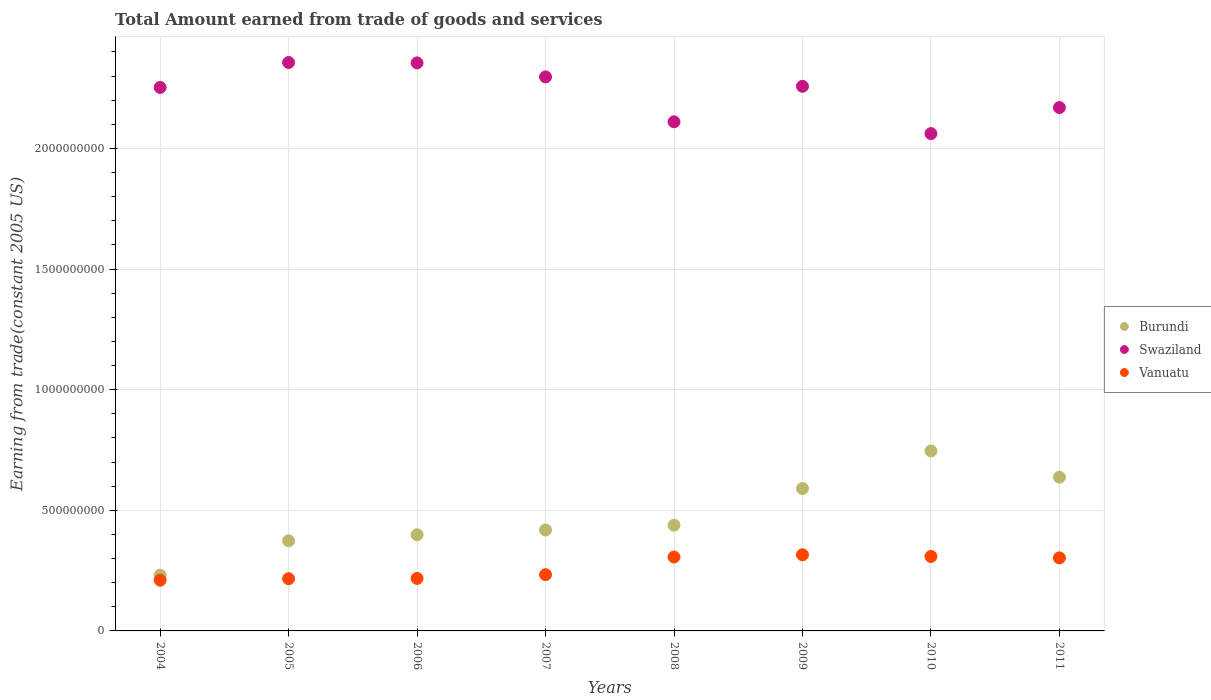How many different coloured dotlines are there?
Provide a short and direct response. 3. Is the number of dotlines equal to the number of legend labels?
Your answer should be compact. Yes. What is the total amount earned by trading goods and services in Burundi in 2004?
Your answer should be compact. 2.31e+08. Across all years, what is the maximum total amount earned by trading goods and services in Vanuatu?
Your answer should be very brief. 3.15e+08. Across all years, what is the minimum total amount earned by trading goods and services in Vanuatu?
Your answer should be compact. 2.10e+08. What is the total total amount earned by trading goods and services in Burundi in the graph?
Offer a terse response. 3.83e+09. What is the difference between the total amount earned by trading goods and services in Vanuatu in 2006 and that in 2007?
Offer a terse response. -1.54e+07. What is the difference between the total amount earned by trading goods and services in Swaziland in 2006 and the total amount earned by trading goods and services in Burundi in 2007?
Your response must be concise. 1.94e+09. What is the average total amount earned by trading goods and services in Burundi per year?
Make the answer very short. 4.79e+08. In the year 2007, what is the difference between the total amount earned by trading goods and services in Swaziland and total amount earned by trading goods and services in Burundi?
Give a very brief answer. 1.88e+09. In how many years, is the total amount earned by trading goods and services in Swaziland greater than 2300000000 US$?
Give a very brief answer. 2. What is the ratio of the total amount earned by trading goods and services in Vanuatu in 2004 to that in 2011?
Keep it short and to the point. 0.7. Is the total amount earned by trading goods and services in Swaziland in 2006 less than that in 2011?
Your answer should be very brief. No. Is the difference between the total amount earned by trading goods and services in Swaziland in 2006 and 2008 greater than the difference between the total amount earned by trading goods and services in Burundi in 2006 and 2008?
Make the answer very short. Yes. What is the difference between the highest and the second highest total amount earned by trading goods and services in Swaziland?
Give a very brief answer. 1.81e+06. What is the difference between the highest and the lowest total amount earned by trading goods and services in Vanuatu?
Offer a terse response. 1.05e+08. In how many years, is the total amount earned by trading goods and services in Swaziland greater than the average total amount earned by trading goods and services in Swaziland taken over all years?
Provide a succinct answer. 5. Is the total amount earned by trading goods and services in Vanuatu strictly greater than the total amount earned by trading goods and services in Swaziland over the years?
Your answer should be very brief. No. Is the total amount earned by trading goods and services in Burundi strictly less than the total amount earned by trading goods and services in Swaziland over the years?
Make the answer very short. Yes. How many dotlines are there?
Your response must be concise. 3. Where does the legend appear in the graph?
Ensure brevity in your answer.  Center right. How many legend labels are there?
Give a very brief answer. 3. How are the legend labels stacked?
Make the answer very short. Vertical. What is the title of the graph?
Provide a short and direct response. Total Amount earned from trade of goods and services. What is the label or title of the Y-axis?
Offer a terse response. Earning from trade(constant 2005 US). What is the Earning from trade(constant 2005 US) in Burundi in 2004?
Your response must be concise. 2.31e+08. What is the Earning from trade(constant 2005 US) in Swaziland in 2004?
Your answer should be compact. 2.25e+09. What is the Earning from trade(constant 2005 US) of Vanuatu in 2004?
Offer a terse response. 2.10e+08. What is the Earning from trade(constant 2005 US) of Burundi in 2005?
Your response must be concise. 3.74e+08. What is the Earning from trade(constant 2005 US) in Swaziland in 2005?
Your response must be concise. 2.36e+09. What is the Earning from trade(constant 2005 US) in Vanuatu in 2005?
Ensure brevity in your answer.  2.16e+08. What is the Earning from trade(constant 2005 US) of Burundi in 2006?
Keep it short and to the point. 3.99e+08. What is the Earning from trade(constant 2005 US) in Swaziland in 2006?
Your answer should be very brief. 2.35e+09. What is the Earning from trade(constant 2005 US) of Vanuatu in 2006?
Give a very brief answer. 2.18e+08. What is the Earning from trade(constant 2005 US) in Burundi in 2007?
Keep it short and to the point. 4.18e+08. What is the Earning from trade(constant 2005 US) in Swaziland in 2007?
Ensure brevity in your answer.  2.30e+09. What is the Earning from trade(constant 2005 US) of Vanuatu in 2007?
Ensure brevity in your answer.  2.33e+08. What is the Earning from trade(constant 2005 US) in Burundi in 2008?
Keep it short and to the point. 4.38e+08. What is the Earning from trade(constant 2005 US) of Swaziland in 2008?
Your response must be concise. 2.11e+09. What is the Earning from trade(constant 2005 US) of Vanuatu in 2008?
Offer a terse response. 3.06e+08. What is the Earning from trade(constant 2005 US) in Burundi in 2009?
Your answer should be very brief. 5.90e+08. What is the Earning from trade(constant 2005 US) in Swaziland in 2009?
Make the answer very short. 2.26e+09. What is the Earning from trade(constant 2005 US) in Vanuatu in 2009?
Provide a succinct answer. 3.15e+08. What is the Earning from trade(constant 2005 US) of Burundi in 2010?
Your response must be concise. 7.46e+08. What is the Earning from trade(constant 2005 US) of Swaziland in 2010?
Your answer should be very brief. 2.06e+09. What is the Earning from trade(constant 2005 US) of Vanuatu in 2010?
Offer a terse response. 3.09e+08. What is the Earning from trade(constant 2005 US) in Burundi in 2011?
Offer a terse response. 6.37e+08. What is the Earning from trade(constant 2005 US) in Swaziland in 2011?
Offer a very short reply. 2.17e+09. What is the Earning from trade(constant 2005 US) in Vanuatu in 2011?
Offer a very short reply. 3.03e+08. Across all years, what is the maximum Earning from trade(constant 2005 US) of Burundi?
Make the answer very short. 7.46e+08. Across all years, what is the maximum Earning from trade(constant 2005 US) in Swaziland?
Your response must be concise. 2.36e+09. Across all years, what is the maximum Earning from trade(constant 2005 US) of Vanuatu?
Provide a succinct answer. 3.15e+08. Across all years, what is the minimum Earning from trade(constant 2005 US) of Burundi?
Provide a succinct answer. 2.31e+08. Across all years, what is the minimum Earning from trade(constant 2005 US) of Swaziland?
Keep it short and to the point. 2.06e+09. Across all years, what is the minimum Earning from trade(constant 2005 US) in Vanuatu?
Provide a short and direct response. 2.10e+08. What is the total Earning from trade(constant 2005 US) of Burundi in the graph?
Make the answer very short. 3.83e+09. What is the total Earning from trade(constant 2005 US) of Swaziland in the graph?
Keep it short and to the point. 1.79e+1. What is the total Earning from trade(constant 2005 US) of Vanuatu in the graph?
Offer a very short reply. 2.11e+09. What is the difference between the Earning from trade(constant 2005 US) of Burundi in 2004 and that in 2005?
Provide a succinct answer. -1.43e+08. What is the difference between the Earning from trade(constant 2005 US) in Swaziland in 2004 and that in 2005?
Ensure brevity in your answer.  -1.04e+08. What is the difference between the Earning from trade(constant 2005 US) in Vanuatu in 2004 and that in 2005?
Ensure brevity in your answer.  -6.03e+06. What is the difference between the Earning from trade(constant 2005 US) of Burundi in 2004 and that in 2006?
Give a very brief answer. -1.67e+08. What is the difference between the Earning from trade(constant 2005 US) of Swaziland in 2004 and that in 2006?
Ensure brevity in your answer.  -1.02e+08. What is the difference between the Earning from trade(constant 2005 US) of Vanuatu in 2004 and that in 2006?
Give a very brief answer. -7.32e+06. What is the difference between the Earning from trade(constant 2005 US) in Burundi in 2004 and that in 2007?
Make the answer very short. -1.87e+08. What is the difference between the Earning from trade(constant 2005 US) in Swaziland in 2004 and that in 2007?
Ensure brevity in your answer.  -4.36e+07. What is the difference between the Earning from trade(constant 2005 US) in Vanuatu in 2004 and that in 2007?
Give a very brief answer. -2.28e+07. What is the difference between the Earning from trade(constant 2005 US) in Burundi in 2004 and that in 2008?
Give a very brief answer. -2.07e+08. What is the difference between the Earning from trade(constant 2005 US) in Swaziland in 2004 and that in 2008?
Provide a short and direct response. 1.42e+08. What is the difference between the Earning from trade(constant 2005 US) in Vanuatu in 2004 and that in 2008?
Your answer should be very brief. -9.61e+07. What is the difference between the Earning from trade(constant 2005 US) in Burundi in 2004 and that in 2009?
Provide a succinct answer. -3.59e+08. What is the difference between the Earning from trade(constant 2005 US) in Swaziland in 2004 and that in 2009?
Ensure brevity in your answer.  -4.71e+06. What is the difference between the Earning from trade(constant 2005 US) in Vanuatu in 2004 and that in 2009?
Offer a terse response. -1.05e+08. What is the difference between the Earning from trade(constant 2005 US) of Burundi in 2004 and that in 2010?
Offer a very short reply. -5.15e+08. What is the difference between the Earning from trade(constant 2005 US) of Swaziland in 2004 and that in 2010?
Give a very brief answer. 1.91e+08. What is the difference between the Earning from trade(constant 2005 US) in Vanuatu in 2004 and that in 2010?
Provide a succinct answer. -9.83e+07. What is the difference between the Earning from trade(constant 2005 US) in Burundi in 2004 and that in 2011?
Ensure brevity in your answer.  -4.06e+08. What is the difference between the Earning from trade(constant 2005 US) in Swaziland in 2004 and that in 2011?
Offer a terse response. 8.34e+07. What is the difference between the Earning from trade(constant 2005 US) of Vanuatu in 2004 and that in 2011?
Your response must be concise. -9.23e+07. What is the difference between the Earning from trade(constant 2005 US) in Burundi in 2005 and that in 2006?
Your answer should be compact. -2.49e+07. What is the difference between the Earning from trade(constant 2005 US) of Swaziland in 2005 and that in 2006?
Provide a short and direct response. 1.81e+06. What is the difference between the Earning from trade(constant 2005 US) of Vanuatu in 2005 and that in 2006?
Provide a short and direct response. -1.29e+06. What is the difference between the Earning from trade(constant 2005 US) in Burundi in 2005 and that in 2007?
Your answer should be very brief. -4.48e+07. What is the difference between the Earning from trade(constant 2005 US) in Swaziland in 2005 and that in 2007?
Offer a terse response. 5.99e+07. What is the difference between the Earning from trade(constant 2005 US) of Vanuatu in 2005 and that in 2007?
Your response must be concise. -1.67e+07. What is the difference between the Earning from trade(constant 2005 US) in Burundi in 2005 and that in 2008?
Provide a short and direct response. -6.44e+07. What is the difference between the Earning from trade(constant 2005 US) of Swaziland in 2005 and that in 2008?
Give a very brief answer. 2.46e+08. What is the difference between the Earning from trade(constant 2005 US) in Vanuatu in 2005 and that in 2008?
Offer a very short reply. -9.00e+07. What is the difference between the Earning from trade(constant 2005 US) of Burundi in 2005 and that in 2009?
Provide a short and direct response. -2.17e+08. What is the difference between the Earning from trade(constant 2005 US) of Swaziland in 2005 and that in 2009?
Your response must be concise. 9.89e+07. What is the difference between the Earning from trade(constant 2005 US) in Vanuatu in 2005 and that in 2009?
Provide a short and direct response. -9.91e+07. What is the difference between the Earning from trade(constant 2005 US) of Burundi in 2005 and that in 2010?
Provide a succinct answer. -3.72e+08. What is the difference between the Earning from trade(constant 2005 US) in Swaziland in 2005 and that in 2010?
Offer a terse response. 2.95e+08. What is the difference between the Earning from trade(constant 2005 US) of Vanuatu in 2005 and that in 2010?
Your answer should be very brief. -9.22e+07. What is the difference between the Earning from trade(constant 2005 US) in Burundi in 2005 and that in 2011?
Give a very brief answer. -2.64e+08. What is the difference between the Earning from trade(constant 2005 US) of Swaziland in 2005 and that in 2011?
Your response must be concise. 1.87e+08. What is the difference between the Earning from trade(constant 2005 US) in Vanuatu in 2005 and that in 2011?
Offer a very short reply. -8.63e+07. What is the difference between the Earning from trade(constant 2005 US) in Burundi in 2006 and that in 2007?
Make the answer very short. -1.99e+07. What is the difference between the Earning from trade(constant 2005 US) of Swaziland in 2006 and that in 2007?
Ensure brevity in your answer.  5.81e+07. What is the difference between the Earning from trade(constant 2005 US) of Vanuatu in 2006 and that in 2007?
Offer a terse response. -1.54e+07. What is the difference between the Earning from trade(constant 2005 US) of Burundi in 2006 and that in 2008?
Offer a very short reply. -3.96e+07. What is the difference between the Earning from trade(constant 2005 US) of Swaziland in 2006 and that in 2008?
Keep it short and to the point. 2.44e+08. What is the difference between the Earning from trade(constant 2005 US) in Vanuatu in 2006 and that in 2008?
Offer a very short reply. -8.87e+07. What is the difference between the Earning from trade(constant 2005 US) of Burundi in 2006 and that in 2009?
Your answer should be very brief. -1.92e+08. What is the difference between the Earning from trade(constant 2005 US) of Swaziland in 2006 and that in 2009?
Your answer should be compact. 9.70e+07. What is the difference between the Earning from trade(constant 2005 US) in Vanuatu in 2006 and that in 2009?
Offer a very short reply. -9.78e+07. What is the difference between the Earning from trade(constant 2005 US) in Burundi in 2006 and that in 2010?
Provide a succinct answer. -3.47e+08. What is the difference between the Earning from trade(constant 2005 US) in Swaziland in 2006 and that in 2010?
Make the answer very short. 2.93e+08. What is the difference between the Earning from trade(constant 2005 US) of Vanuatu in 2006 and that in 2010?
Provide a short and direct response. -9.09e+07. What is the difference between the Earning from trade(constant 2005 US) in Burundi in 2006 and that in 2011?
Provide a short and direct response. -2.39e+08. What is the difference between the Earning from trade(constant 2005 US) in Swaziland in 2006 and that in 2011?
Keep it short and to the point. 1.85e+08. What is the difference between the Earning from trade(constant 2005 US) of Vanuatu in 2006 and that in 2011?
Provide a short and direct response. -8.50e+07. What is the difference between the Earning from trade(constant 2005 US) of Burundi in 2007 and that in 2008?
Give a very brief answer. -1.96e+07. What is the difference between the Earning from trade(constant 2005 US) in Swaziland in 2007 and that in 2008?
Offer a terse response. 1.86e+08. What is the difference between the Earning from trade(constant 2005 US) in Vanuatu in 2007 and that in 2008?
Make the answer very short. -7.33e+07. What is the difference between the Earning from trade(constant 2005 US) in Burundi in 2007 and that in 2009?
Ensure brevity in your answer.  -1.72e+08. What is the difference between the Earning from trade(constant 2005 US) in Swaziland in 2007 and that in 2009?
Keep it short and to the point. 3.89e+07. What is the difference between the Earning from trade(constant 2005 US) of Vanuatu in 2007 and that in 2009?
Your answer should be compact. -8.23e+07. What is the difference between the Earning from trade(constant 2005 US) in Burundi in 2007 and that in 2010?
Your response must be concise. -3.27e+08. What is the difference between the Earning from trade(constant 2005 US) in Swaziland in 2007 and that in 2010?
Keep it short and to the point. 2.35e+08. What is the difference between the Earning from trade(constant 2005 US) of Vanuatu in 2007 and that in 2010?
Your answer should be very brief. -7.55e+07. What is the difference between the Earning from trade(constant 2005 US) of Burundi in 2007 and that in 2011?
Your response must be concise. -2.19e+08. What is the difference between the Earning from trade(constant 2005 US) in Swaziland in 2007 and that in 2011?
Ensure brevity in your answer.  1.27e+08. What is the difference between the Earning from trade(constant 2005 US) in Vanuatu in 2007 and that in 2011?
Ensure brevity in your answer.  -6.95e+07. What is the difference between the Earning from trade(constant 2005 US) in Burundi in 2008 and that in 2009?
Your answer should be very brief. -1.52e+08. What is the difference between the Earning from trade(constant 2005 US) in Swaziland in 2008 and that in 2009?
Provide a succinct answer. -1.47e+08. What is the difference between the Earning from trade(constant 2005 US) of Vanuatu in 2008 and that in 2009?
Make the answer very short. -9.04e+06. What is the difference between the Earning from trade(constant 2005 US) in Burundi in 2008 and that in 2010?
Offer a terse response. -3.08e+08. What is the difference between the Earning from trade(constant 2005 US) in Swaziland in 2008 and that in 2010?
Make the answer very short. 4.89e+07. What is the difference between the Earning from trade(constant 2005 US) in Vanuatu in 2008 and that in 2010?
Your response must be concise. -2.21e+06. What is the difference between the Earning from trade(constant 2005 US) of Burundi in 2008 and that in 2011?
Your answer should be compact. -1.99e+08. What is the difference between the Earning from trade(constant 2005 US) in Swaziland in 2008 and that in 2011?
Your answer should be very brief. -5.91e+07. What is the difference between the Earning from trade(constant 2005 US) in Vanuatu in 2008 and that in 2011?
Your answer should be very brief. 3.74e+06. What is the difference between the Earning from trade(constant 2005 US) in Burundi in 2009 and that in 2010?
Provide a short and direct response. -1.56e+08. What is the difference between the Earning from trade(constant 2005 US) of Swaziland in 2009 and that in 2010?
Ensure brevity in your answer.  1.96e+08. What is the difference between the Earning from trade(constant 2005 US) of Vanuatu in 2009 and that in 2010?
Offer a very short reply. 6.83e+06. What is the difference between the Earning from trade(constant 2005 US) in Burundi in 2009 and that in 2011?
Make the answer very short. -4.70e+07. What is the difference between the Earning from trade(constant 2005 US) of Swaziland in 2009 and that in 2011?
Keep it short and to the point. 8.81e+07. What is the difference between the Earning from trade(constant 2005 US) of Vanuatu in 2009 and that in 2011?
Provide a succinct answer. 1.28e+07. What is the difference between the Earning from trade(constant 2005 US) of Burundi in 2010 and that in 2011?
Give a very brief answer. 1.09e+08. What is the difference between the Earning from trade(constant 2005 US) in Swaziland in 2010 and that in 2011?
Offer a very short reply. -1.08e+08. What is the difference between the Earning from trade(constant 2005 US) in Vanuatu in 2010 and that in 2011?
Your response must be concise. 5.95e+06. What is the difference between the Earning from trade(constant 2005 US) of Burundi in 2004 and the Earning from trade(constant 2005 US) of Swaziland in 2005?
Provide a short and direct response. -2.13e+09. What is the difference between the Earning from trade(constant 2005 US) in Burundi in 2004 and the Earning from trade(constant 2005 US) in Vanuatu in 2005?
Ensure brevity in your answer.  1.47e+07. What is the difference between the Earning from trade(constant 2005 US) in Swaziland in 2004 and the Earning from trade(constant 2005 US) in Vanuatu in 2005?
Provide a succinct answer. 2.04e+09. What is the difference between the Earning from trade(constant 2005 US) in Burundi in 2004 and the Earning from trade(constant 2005 US) in Swaziland in 2006?
Offer a terse response. -2.12e+09. What is the difference between the Earning from trade(constant 2005 US) in Burundi in 2004 and the Earning from trade(constant 2005 US) in Vanuatu in 2006?
Your answer should be very brief. 1.34e+07. What is the difference between the Earning from trade(constant 2005 US) of Swaziland in 2004 and the Earning from trade(constant 2005 US) of Vanuatu in 2006?
Keep it short and to the point. 2.04e+09. What is the difference between the Earning from trade(constant 2005 US) in Burundi in 2004 and the Earning from trade(constant 2005 US) in Swaziland in 2007?
Give a very brief answer. -2.07e+09. What is the difference between the Earning from trade(constant 2005 US) of Burundi in 2004 and the Earning from trade(constant 2005 US) of Vanuatu in 2007?
Provide a short and direct response. -2.07e+06. What is the difference between the Earning from trade(constant 2005 US) in Swaziland in 2004 and the Earning from trade(constant 2005 US) in Vanuatu in 2007?
Provide a short and direct response. 2.02e+09. What is the difference between the Earning from trade(constant 2005 US) in Burundi in 2004 and the Earning from trade(constant 2005 US) in Swaziland in 2008?
Give a very brief answer. -1.88e+09. What is the difference between the Earning from trade(constant 2005 US) of Burundi in 2004 and the Earning from trade(constant 2005 US) of Vanuatu in 2008?
Give a very brief answer. -7.54e+07. What is the difference between the Earning from trade(constant 2005 US) in Swaziland in 2004 and the Earning from trade(constant 2005 US) in Vanuatu in 2008?
Offer a very short reply. 1.95e+09. What is the difference between the Earning from trade(constant 2005 US) in Burundi in 2004 and the Earning from trade(constant 2005 US) in Swaziland in 2009?
Keep it short and to the point. -2.03e+09. What is the difference between the Earning from trade(constant 2005 US) of Burundi in 2004 and the Earning from trade(constant 2005 US) of Vanuatu in 2009?
Your answer should be very brief. -8.44e+07. What is the difference between the Earning from trade(constant 2005 US) of Swaziland in 2004 and the Earning from trade(constant 2005 US) of Vanuatu in 2009?
Offer a terse response. 1.94e+09. What is the difference between the Earning from trade(constant 2005 US) in Burundi in 2004 and the Earning from trade(constant 2005 US) in Swaziland in 2010?
Provide a short and direct response. -1.83e+09. What is the difference between the Earning from trade(constant 2005 US) of Burundi in 2004 and the Earning from trade(constant 2005 US) of Vanuatu in 2010?
Offer a very short reply. -7.76e+07. What is the difference between the Earning from trade(constant 2005 US) of Swaziland in 2004 and the Earning from trade(constant 2005 US) of Vanuatu in 2010?
Make the answer very short. 1.94e+09. What is the difference between the Earning from trade(constant 2005 US) of Burundi in 2004 and the Earning from trade(constant 2005 US) of Swaziland in 2011?
Offer a terse response. -1.94e+09. What is the difference between the Earning from trade(constant 2005 US) in Burundi in 2004 and the Earning from trade(constant 2005 US) in Vanuatu in 2011?
Your answer should be compact. -7.16e+07. What is the difference between the Earning from trade(constant 2005 US) of Swaziland in 2004 and the Earning from trade(constant 2005 US) of Vanuatu in 2011?
Ensure brevity in your answer.  1.95e+09. What is the difference between the Earning from trade(constant 2005 US) in Burundi in 2005 and the Earning from trade(constant 2005 US) in Swaziland in 2006?
Make the answer very short. -1.98e+09. What is the difference between the Earning from trade(constant 2005 US) in Burundi in 2005 and the Earning from trade(constant 2005 US) in Vanuatu in 2006?
Your response must be concise. 1.56e+08. What is the difference between the Earning from trade(constant 2005 US) in Swaziland in 2005 and the Earning from trade(constant 2005 US) in Vanuatu in 2006?
Offer a terse response. 2.14e+09. What is the difference between the Earning from trade(constant 2005 US) of Burundi in 2005 and the Earning from trade(constant 2005 US) of Swaziland in 2007?
Offer a very short reply. -1.92e+09. What is the difference between the Earning from trade(constant 2005 US) of Burundi in 2005 and the Earning from trade(constant 2005 US) of Vanuatu in 2007?
Provide a succinct answer. 1.41e+08. What is the difference between the Earning from trade(constant 2005 US) of Swaziland in 2005 and the Earning from trade(constant 2005 US) of Vanuatu in 2007?
Give a very brief answer. 2.12e+09. What is the difference between the Earning from trade(constant 2005 US) in Burundi in 2005 and the Earning from trade(constant 2005 US) in Swaziland in 2008?
Your response must be concise. -1.74e+09. What is the difference between the Earning from trade(constant 2005 US) of Burundi in 2005 and the Earning from trade(constant 2005 US) of Vanuatu in 2008?
Provide a short and direct response. 6.72e+07. What is the difference between the Earning from trade(constant 2005 US) in Swaziland in 2005 and the Earning from trade(constant 2005 US) in Vanuatu in 2008?
Provide a short and direct response. 2.05e+09. What is the difference between the Earning from trade(constant 2005 US) of Burundi in 2005 and the Earning from trade(constant 2005 US) of Swaziland in 2009?
Offer a terse response. -1.88e+09. What is the difference between the Earning from trade(constant 2005 US) of Burundi in 2005 and the Earning from trade(constant 2005 US) of Vanuatu in 2009?
Keep it short and to the point. 5.82e+07. What is the difference between the Earning from trade(constant 2005 US) of Swaziland in 2005 and the Earning from trade(constant 2005 US) of Vanuatu in 2009?
Keep it short and to the point. 2.04e+09. What is the difference between the Earning from trade(constant 2005 US) of Burundi in 2005 and the Earning from trade(constant 2005 US) of Swaziland in 2010?
Offer a terse response. -1.69e+09. What is the difference between the Earning from trade(constant 2005 US) in Burundi in 2005 and the Earning from trade(constant 2005 US) in Vanuatu in 2010?
Make the answer very short. 6.50e+07. What is the difference between the Earning from trade(constant 2005 US) in Swaziland in 2005 and the Earning from trade(constant 2005 US) in Vanuatu in 2010?
Make the answer very short. 2.05e+09. What is the difference between the Earning from trade(constant 2005 US) in Burundi in 2005 and the Earning from trade(constant 2005 US) in Swaziland in 2011?
Offer a terse response. -1.80e+09. What is the difference between the Earning from trade(constant 2005 US) in Burundi in 2005 and the Earning from trade(constant 2005 US) in Vanuatu in 2011?
Make the answer very short. 7.10e+07. What is the difference between the Earning from trade(constant 2005 US) in Swaziland in 2005 and the Earning from trade(constant 2005 US) in Vanuatu in 2011?
Provide a succinct answer. 2.05e+09. What is the difference between the Earning from trade(constant 2005 US) in Burundi in 2006 and the Earning from trade(constant 2005 US) in Swaziland in 2007?
Provide a succinct answer. -1.90e+09. What is the difference between the Earning from trade(constant 2005 US) in Burundi in 2006 and the Earning from trade(constant 2005 US) in Vanuatu in 2007?
Your answer should be compact. 1.65e+08. What is the difference between the Earning from trade(constant 2005 US) in Swaziland in 2006 and the Earning from trade(constant 2005 US) in Vanuatu in 2007?
Ensure brevity in your answer.  2.12e+09. What is the difference between the Earning from trade(constant 2005 US) in Burundi in 2006 and the Earning from trade(constant 2005 US) in Swaziland in 2008?
Ensure brevity in your answer.  -1.71e+09. What is the difference between the Earning from trade(constant 2005 US) in Burundi in 2006 and the Earning from trade(constant 2005 US) in Vanuatu in 2008?
Offer a very short reply. 9.21e+07. What is the difference between the Earning from trade(constant 2005 US) in Swaziland in 2006 and the Earning from trade(constant 2005 US) in Vanuatu in 2008?
Make the answer very short. 2.05e+09. What is the difference between the Earning from trade(constant 2005 US) of Burundi in 2006 and the Earning from trade(constant 2005 US) of Swaziland in 2009?
Your answer should be very brief. -1.86e+09. What is the difference between the Earning from trade(constant 2005 US) in Burundi in 2006 and the Earning from trade(constant 2005 US) in Vanuatu in 2009?
Provide a short and direct response. 8.31e+07. What is the difference between the Earning from trade(constant 2005 US) in Swaziland in 2006 and the Earning from trade(constant 2005 US) in Vanuatu in 2009?
Your response must be concise. 2.04e+09. What is the difference between the Earning from trade(constant 2005 US) of Burundi in 2006 and the Earning from trade(constant 2005 US) of Swaziland in 2010?
Your answer should be compact. -1.66e+09. What is the difference between the Earning from trade(constant 2005 US) of Burundi in 2006 and the Earning from trade(constant 2005 US) of Vanuatu in 2010?
Offer a very short reply. 8.99e+07. What is the difference between the Earning from trade(constant 2005 US) of Swaziland in 2006 and the Earning from trade(constant 2005 US) of Vanuatu in 2010?
Offer a terse response. 2.05e+09. What is the difference between the Earning from trade(constant 2005 US) of Burundi in 2006 and the Earning from trade(constant 2005 US) of Swaziland in 2011?
Make the answer very short. -1.77e+09. What is the difference between the Earning from trade(constant 2005 US) in Burundi in 2006 and the Earning from trade(constant 2005 US) in Vanuatu in 2011?
Offer a terse response. 9.58e+07. What is the difference between the Earning from trade(constant 2005 US) of Swaziland in 2006 and the Earning from trade(constant 2005 US) of Vanuatu in 2011?
Give a very brief answer. 2.05e+09. What is the difference between the Earning from trade(constant 2005 US) of Burundi in 2007 and the Earning from trade(constant 2005 US) of Swaziland in 2008?
Your answer should be very brief. -1.69e+09. What is the difference between the Earning from trade(constant 2005 US) in Burundi in 2007 and the Earning from trade(constant 2005 US) in Vanuatu in 2008?
Make the answer very short. 1.12e+08. What is the difference between the Earning from trade(constant 2005 US) of Swaziland in 2007 and the Earning from trade(constant 2005 US) of Vanuatu in 2008?
Give a very brief answer. 1.99e+09. What is the difference between the Earning from trade(constant 2005 US) in Burundi in 2007 and the Earning from trade(constant 2005 US) in Swaziland in 2009?
Your answer should be compact. -1.84e+09. What is the difference between the Earning from trade(constant 2005 US) of Burundi in 2007 and the Earning from trade(constant 2005 US) of Vanuatu in 2009?
Your answer should be very brief. 1.03e+08. What is the difference between the Earning from trade(constant 2005 US) of Swaziland in 2007 and the Earning from trade(constant 2005 US) of Vanuatu in 2009?
Your answer should be very brief. 1.98e+09. What is the difference between the Earning from trade(constant 2005 US) in Burundi in 2007 and the Earning from trade(constant 2005 US) in Swaziland in 2010?
Your answer should be compact. -1.64e+09. What is the difference between the Earning from trade(constant 2005 US) of Burundi in 2007 and the Earning from trade(constant 2005 US) of Vanuatu in 2010?
Offer a very short reply. 1.10e+08. What is the difference between the Earning from trade(constant 2005 US) in Swaziland in 2007 and the Earning from trade(constant 2005 US) in Vanuatu in 2010?
Offer a terse response. 1.99e+09. What is the difference between the Earning from trade(constant 2005 US) of Burundi in 2007 and the Earning from trade(constant 2005 US) of Swaziland in 2011?
Offer a very short reply. -1.75e+09. What is the difference between the Earning from trade(constant 2005 US) of Burundi in 2007 and the Earning from trade(constant 2005 US) of Vanuatu in 2011?
Provide a short and direct response. 1.16e+08. What is the difference between the Earning from trade(constant 2005 US) in Swaziland in 2007 and the Earning from trade(constant 2005 US) in Vanuatu in 2011?
Your answer should be compact. 1.99e+09. What is the difference between the Earning from trade(constant 2005 US) of Burundi in 2008 and the Earning from trade(constant 2005 US) of Swaziland in 2009?
Your answer should be very brief. -1.82e+09. What is the difference between the Earning from trade(constant 2005 US) in Burundi in 2008 and the Earning from trade(constant 2005 US) in Vanuatu in 2009?
Your answer should be compact. 1.23e+08. What is the difference between the Earning from trade(constant 2005 US) of Swaziland in 2008 and the Earning from trade(constant 2005 US) of Vanuatu in 2009?
Offer a very short reply. 1.79e+09. What is the difference between the Earning from trade(constant 2005 US) of Burundi in 2008 and the Earning from trade(constant 2005 US) of Swaziland in 2010?
Your answer should be compact. -1.62e+09. What is the difference between the Earning from trade(constant 2005 US) in Burundi in 2008 and the Earning from trade(constant 2005 US) in Vanuatu in 2010?
Ensure brevity in your answer.  1.29e+08. What is the difference between the Earning from trade(constant 2005 US) in Swaziland in 2008 and the Earning from trade(constant 2005 US) in Vanuatu in 2010?
Provide a succinct answer. 1.80e+09. What is the difference between the Earning from trade(constant 2005 US) in Burundi in 2008 and the Earning from trade(constant 2005 US) in Swaziland in 2011?
Your answer should be compact. -1.73e+09. What is the difference between the Earning from trade(constant 2005 US) in Burundi in 2008 and the Earning from trade(constant 2005 US) in Vanuatu in 2011?
Give a very brief answer. 1.35e+08. What is the difference between the Earning from trade(constant 2005 US) in Swaziland in 2008 and the Earning from trade(constant 2005 US) in Vanuatu in 2011?
Give a very brief answer. 1.81e+09. What is the difference between the Earning from trade(constant 2005 US) of Burundi in 2009 and the Earning from trade(constant 2005 US) of Swaziland in 2010?
Provide a short and direct response. -1.47e+09. What is the difference between the Earning from trade(constant 2005 US) of Burundi in 2009 and the Earning from trade(constant 2005 US) of Vanuatu in 2010?
Give a very brief answer. 2.82e+08. What is the difference between the Earning from trade(constant 2005 US) of Swaziland in 2009 and the Earning from trade(constant 2005 US) of Vanuatu in 2010?
Offer a terse response. 1.95e+09. What is the difference between the Earning from trade(constant 2005 US) of Burundi in 2009 and the Earning from trade(constant 2005 US) of Swaziland in 2011?
Make the answer very short. -1.58e+09. What is the difference between the Earning from trade(constant 2005 US) in Burundi in 2009 and the Earning from trade(constant 2005 US) in Vanuatu in 2011?
Provide a short and direct response. 2.87e+08. What is the difference between the Earning from trade(constant 2005 US) of Swaziland in 2009 and the Earning from trade(constant 2005 US) of Vanuatu in 2011?
Ensure brevity in your answer.  1.95e+09. What is the difference between the Earning from trade(constant 2005 US) in Burundi in 2010 and the Earning from trade(constant 2005 US) in Swaziland in 2011?
Ensure brevity in your answer.  -1.42e+09. What is the difference between the Earning from trade(constant 2005 US) of Burundi in 2010 and the Earning from trade(constant 2005 US) of Vanuatu in 2011?
Provide a succinct answer. 4.43e+08. What is the difference between the Earning from trade(constant 2005 US) of Swaziland in 2010 and the Earning from trade(constant 2005 US) of Vanuatu in 2011?
Your answer should be very brief. 1.76e+09. What is the average Earning from trade(constant 2005 US) of Burundi per year?
Provide a succinct answer. 4.79e+08. What is the average Earning from trade(constant 2005 US) in Swaziland per year?
Keep it short and to the point. 2.23e+09. What is the average Earning from trade(constant 2005 US) in Vanuatu per year?
Provide a succinct answer. 2.64e+08. In the year 2004, what is the difference between the Earning from trade(constant 2005 US) of Burundi and Earning from trade(constant 2005 US) of Swaziland?
Give a very brief answer. -2.02e+09. In the year 2004, what is the difference between the Earning from trade(constant 2005 US) of Burundi and Earning from trade(constant 2005 US) of Vanuatu?
Provide a short and direct response. 2.07e+07. In the year 2004, what is the difference between the Earning from trade(constant 2005 US) of Swaziland and Earning from trade(constant 2005 US) of Vanuatu?
Make the answer very short. 2.04e+09. In the year 2005, what is the difference between the Earning from trade(constant 2005 US) of Burundi and Earning from trade(constant 2005 US) of Swaziland?
Offer a very short reply. -1.98e+09. In the year 2005, what is the difference between the Earning from trade(constant 2005 US) of Burundi and Earning from trade(constant 2005 US) of Vanuatu?
Your answer should be very brief. 1.57e+08. In the year 2005, what is the difference between the Earning from trade(constant 2005 US) in Swaziland and Earning from trade(constant 2005 US) in Vanuatu?
Offer a terse response. 2.14e+09. In the year 2006, what is the difference between the Earning from trade(constant 2005 US) of Burundi and Earning from trade(constant 2005 US) of Swaziland?
Your response must be concise. -1.96e+09. In the year 2006, what is the difference between the Earning from trade(constant 2005 US) of Burundi and Earning from trade(constant 2005 US) of Vanuatu?
Give a very brief answer. 1.81e+08. In the year 2006, what is the difference between the Earning from trade(constant 2005 US) in Swaziland and Earning from trade(constant 2005 US) in Vanuatu?
Keep it short and to the point. 2.14e+09. In the year 2007, what is the difference between the Earning from trade(constant 2005 US) in Burundi and Earning from trade(constant 2005 US) in Swaziland?
Your answer should be compact. -1.88e+09. In the year 2007, what is the difference between the Earning from trade(constant 2005 US) in Burundi and Earning from trade(constant 2005 US) in Vanuatu?
Provide a short and direct response. 1.85e+08. In the year 2007, what is the difference between the Earning from trade(constant 2005 US) in Swaziland and Earning from trade(constant 2005 US) in Vanuatu?
Make the answer very short. 2.06e+09. In the year 2008, what is the difference between the Earning from trade(constant 2005 US) in Burundi and Earning from trade(constant 2005 US) in Swaziland?
Your answer should be very brief. -1.67e+09. In the year 2008, what is the difference between the Earning from trade(constant 2005 US) in Burundi and Earning from trade(constant 2005 US) in Vanuatu?
Make the answer very short. 1.32e+08. In the year 2008, what is the difference between the Earning from trade(constant 2005 US) of Swaziland and Earning from trade(constant 2005 US) of Vanuatu?
Keep it short and to the point. 1.80e+09. In the year 2009, what is the difference between the Earning from trade(constant 2005 US) of Burundi and Earning from trade(constant 2005 US) of Swaziland?
Make the answer very short. -1.67e+09. In the year 2009, what is the difference between the Earning from trade(constant 2005 US) of Burundi and Earning from trade(constant 2005 US) of Vanuatu?
Offer a very short reply. 2.75e+08. In the year 2009, what is the difference between the Earning from trade(constant 2005 US) of Swaziland and Earning from trade(constant 2005 US) of Vanuatu?
Ensure brevity in your answer.  1.94e+09. In the year 2010, what is the difference between the Earning from trade(constant 2005 US) in Burundi and Earning from trade(constant 2005 US) in Swaziland?
Your answer should be compact. -1.32e+09. In the year 2010, what is the difference between the Earning from trade(constant 2005 US) of Burundi and Earning from trade(constant 2005 US) of Vanuatu?
Your answer should be compact. 4.37e+08. In the year 2010, what is the difference between the Earning from trade(constant 2005 US) in Swaziland and Earning from trade(constant 2005 US) in Vanuatu?
Offer a very short reply. 1.75e+09. In the year 2011, what is the difference between the Earning from trade(constant 2005 US) of Burundi and Earning from trade(constant 2005 US) of Swaziland?
Your answer should be compact. -1.53e+09. In the year 2011, what is the difference between the Earning from trade(constant 2005 US) of Burundi and Earning from trade(constant 2005 US) of Vanuatu?
Offer a very short reply. 3.34e+08. In the year 2011, what is the difference between the Earning from trade(constant 2005 US) of Swaziland and Earning from trade(constant 2005 US) of Vanuatu?
Provide a succinct answer. 1.87e+09. What is the ratio of the Earning from trade(constant 2005 US) in Burundi in 2004 to that in 2005?
Offer a very short reply. 0.62. What is the ratio of the Earning from trade(constant 2005 US) in Swaziland in 2004 to that in 2005?
Provide a succinct answer. 0.96. What is the ratio of the Earning from trade(constant 2005 US) of Vanuatu in 2004 to that in 2005?
Make the answer very short. 0.97. What is the ratio of the Earning from trade(constant 2005 US) of Burundi in 2004 to that in 2006?
Give a very brief answer. 0.58. What is the ratio of the Earning from trade(constant 2005 US) in Swaziland in 2004 to that in 2006?
Offer a terse response. 0.96. What is the ratio of the Earning from trade(constant 2005 US) in Vanuatu in 2004 to that in 2006?
Offer a terse response. 0.97. What is the ratio of the Earning from trade(constant 2005 US) of Burundi in 2004 to that in 2007?
Provide a short and direct response. 0.55. What is the ratio of the Earning from trade(constant 2005 US) in Vanuatu in 2004 to that in 2007?
Keep it short and to the point. 0.9. What is the ratio of the Earning from trade(constant 2005 US) in Burundi in 2004 to that in 2008?
Your answer should be compact. 0.53. What is the ratio of the Earning from trade(constant 2005 US) of Swaziland in 2004 to that in 2008?
Give a very brief answer. 1.07. What is the ratio of the Earning from trade(constant 2005 US) of Vanuatu in 2004 to that in 2008?
Keep it short and to the point. 0.69. What is the ratio of the Earning from trade(constant 2005 US) of Burundi in 2004 to that in 2009?
Make the answer very short. 0.39. What is the ratio of the Earning from trade(constant 2005 US) in Swaziland in 2004 to that in 2009?
Your answer should be very brief. 1. What is the ratio of the Earning from trade(constant 2005 US) of Vanuatu in 2004 to that in 2009?
Provide a short and direct response. 0.67. What is the ratio of the Earning from trade(constant 2005 US) of Burundi in 2004 to that in 2010?
Ensure brevity in your answer.  0.31. What is the ratio of the Earning from trade(constant 2005 US) in Swaziland in 2004 to that in 2010?
Your answer should be compact. 1.09. What is the ratio of the Earning from trade(constant 2005 US) in Vanuatu in 2004 to that in 2010?
Provide a succinct answer. 0.68. What is the ratio of the Earning from trade(constant 2005 US) in Burundi in 2004 to that in 2011?
Your answer should be compact. 0.36. What is the ratio of the Earning from trade(constant 2005 US) in Swaziland in 2004 to that in 2011?
Offer a very short reply. 1.04. What is the ratio of the Earning from trade(constant 2005 US) in Vanuatu in 2004 to that in 2011?
Your answer should be very brief. 0.69. What is the ratio of the Earning from trade(constant 2005 US) in Burundi in 2005 to that in 2006?
Your response must be concise. 0.94. What is the ratio of the Earning from trade(constant 2005 US) in Swaziland in 2005 to that in 2006?
Ensure brevity in your answer.  1. What is the ratio of the Earning from trade(constant 2005 US) in Vanuatu in 2005 to that in 2006?
Give a very brief answer. 0.99. What is the ratio of the Earning from trade(constant 2005 US) in Burundi in 2005 to that in 2007?
Provide a short and direct response. 0.89. What is the ratio of the Earning from trade(constant 2005 US) of Swaziland in 2005 to that in 2007?
Your answer should be very brief. 1.03. What is the ratio of the Earning from trade(constant 2005 US) in Vanuatu in 2005 to that in 2007?
Provide a short and direct response. 0.93. What is the ratio of the Earning from trade(constant 2005 US) of Burundi in 2005 to that in 2008?
Ensure brevity in your answer.  0.85. What is the ratio of the Earning from trade(constant 2005 US) in Swaziland in 2005 to that in 2008?
Your response must be concise. 1.12. What is the ratio of the Earning from trade(constant 2005 US) of Vanuatu in 2005 to that in 2008?
Provide a short and direct response. 0.71. What is the ratio of the Earning from trade(constant 2005 US) of Burundi in 2005 to that in 2009?
Provide a short and direct response. 0.63. What is the ratio of the Earning from trade(constant 2005 US) in Swaziland in 2005 to that in 2009?
Offer a terse response. 1.04. What is the ratio of the Earning from trade(constant 2005 US) of Vanuatu in 2005 to that in 2009?
Provide a short and direct response. 0.69. What is the ratio of the Earning from trade(constant 2005 US) in Burundi in 2005 to that in 2010?
Provide a short and direct response. 0.5. What is the ratio of the Earning from trade(constant 2005 US) in Swaziland in 2005 to that in 2010?
Provide a succinct answer. 1.14. What is the ratio of the Earning from trade(constant 2005 US) in Vanuatu in 2005 to that in 2010?
Your answer should be very brief. 0.7. What is the ratio of the Earning from trade(constant 2005 US) of Burundi in 2005 to that in 2011?
Ensure brevity in your answer.  0.59. What is the ratio of the Earning from trade(constant 2005 US) in Swaziland in 2005 to that in 2011?
Offer a terse response. 1.09. What is the ratio of the Earning from trade(constant 2005 US) of Vanuatu in 2005 to that in 2011?
Provide a short and direct response. 0.71. What is the ratio of the Earning from trade(constant 2005 US) of Burundi in 2006 to that in 2007?
Your answer should be very brief. 0.95. What is the ratio of the Earning from trade(constant 2005 US) in Swaziland in 2006 to that in 2007?
Make the answer very short. 1.03. What is the ratio of the Earning from trade(constant 2005 US) in Vanuatu in 2006 to that in 2007?
Your answer should be very brief. 0.93. What is the ratio of the Earning from trade(constant 2005 US) in Burundi in 2006 to that in 2008?
Give a very brief answer. 0.91. What is the ratio of the Earning from trade(constant 2005 US) of Swaziland in 2006 to that in 2008?
Your response must be concise. 1.12. What is the ratio of the Earning from trade(constant 2005 US) of Vanuatu in 2006 to that in 2008?
Make the answer very short. 0.71. What is the ratio of the Earning from trade(constant 2005 US) in Burundi in 2006 to that in 2009?
Provide a succinct answer. 0.68. What is the ratio of the Earning from trade(constant 2005 US) in Swaziland in 2006 to that in 2009?
Keep it short and to the point. 1.04. What is the ratio of the Earning from trade(constant 2005 US) of Vanuatu in 2006 to that in 2009?
Offer a terse response. 0.69. What is the ratio of the Earning from trade(constant 2005 US) of Burundi in 2006 to that in 2010?
Make the answer very short. 0.53. What is the ratio of the Earning from trade(constant 2005 US) in Swaziland in 2006 to that in 2010?
Your answer should be very brief. 1.14. What is the ratio of the Earning from trade(constant 2005 US) of Vanuatu in 2006 to that in 2010?
Provide a short and direct response. 0.71. What is the ratio of the Earning from trade(constant 2005 US) of Burundi in 2006 to that in 2011?
Your response must be concise. 0.63. What is the ratio of the Earning from trade(constant 2005 US) in Swaziland in 2006 to that in 2011?
Provide a succinct answer. 1.09. What is the ratio of the Earning from trade(constant 2005 US) of Vanuatu in 2006 to that in 2011?
Your response must be concise. 0.72. What is the ratio of the Earning from trade(constant 2005 US) of Burundi in 2007 to that in 2008?
Give a very brief answer. 0.96. What is the ratio of the Earning from trade(constant 2005 US) in Swaziland in 2007 to that in 2008?
Provide a succinct answer. 1.09. What is the ratio of the Earning from trade(constant 2005 US) of Vanuatu in 2007 to that in 2008?
Offer a terse response. 0.76. What is the ratio of the Earning from trade(constant 2005 US) in Burundi in 2007 to that in 2009?
Ensure brevity in your answer.  0.71. What is the ratio of the Earning from trade(constant 2005 US) of Swaziland in 2007 to that in 2009?
Provide a succinct answer. 1.02. What is the ratio of the Earning from trade(constant 2005 US) in Vanuatu in 2007 to that in 2009?
Your answer should be compact. 0.74. What is the ratio of the Earning from trade(constant 2005 US) in Burundi in 2007 to that in 2010?
Keep it short and to the point. 0.56. What is the ratio of the Earning from trade(constant 2005 US) of Swaziland in 2007 to that in 2010?
Your response must be concise. 1.11. What is the ratio of the Earning from trade(constant 2005 US) of Vanuatu in 2007 to that in 2010?
Offer a terse response. 0.76. What is the ratio of the Earning from trade(constant 2005 US) in Burundi in 2007 to that in 2011?
Make the answer very short. 0.66. What is the ratio of the Earning from trade(constant 2005 US) in Swaziland in 2007 to that in 2011?
Keep it short and to the point. 1.06. What is the ratio of the Earning from trade(constant 2005 US) of Vanuatu in 2007 to that in 2011?
Keep it short and to the point. 0.77. What is the ratio of the Earning from trade(constant 2005 US) in Burundi in 2008 to that in 2009?
Keep it short and to the point. 0.74. What is the ratio of the Earning from trade(constant 2005 US) of Swaziland in 2008 to that in 2009?
Offer a terse response. 0.93. What is the ratio of the Earning from trade(constant 2005 US) in Vanuatu in 2008 to that in 2009?
Provide a short and direct response. 0.97. What is the ratio of the Earning from trade(constant 2005 US) of Burundi in 2008 to that in 2010?
Your answer should be very brief. 0.59. What is the ratio of the Earning from trade(constant 2005 US) in Swaziland in 2008 to that in 2010?
Ensure brevity in your answer.  1.02. What is the ratio of the Earning from trade(constant 2005 US) in Burundi in 2008 to that in 2011?
Offer a very short reply. 0.69. What is the ratio of the Earning from trade(constant 2005 US) in Swaziland in 2008 to that in 2011?
Ensure brevity in your answer.  0.97. What is the ratio of the Earning from trade(constant 2005 US) in Vanuatu in 2008 to that in 2011?
Ensure brevity in your answer.  1.01. What is the ratio of the Earning from trade(constant 2005 US) of Burundi in 2009 to that in 2010?
Keep it short and to the point. 0.79. What is the ratio of the Earning from trade(constant 2005 US) of Swaziland in 2009 to that in 2010?
Offer a terse response. 1.1. What is the ratio of the Earning from trade(constant 2005 US) of Vanuatu in 2009 to that in 2010?
Provide a short and direct response. 1.02. What is the ratio of the Earning from trade(constant 2005 US) of Burundi in 2009 to that in 2011?
Keep it short and to the point. 0.93. What is the ratio of the Earning from trade(constant 2005 US) of Swaziland in 2009 to that in 2011?
Provide a succinct answer. 1.04. What is the ratio of the Earning from trade(constant 2005 US) in Vanuatu in 2009 to that in 2011?
Offer a terse response. 1.04. What is the ratio of the Earning from trade(constant 2005 US) of Burundi in 2010 to that in 2011?
Offer a terse response. 1.17. What is the ratio of the Earning from trade(constant 2005 US) in Swaziland in 2010 to that in 2011?
Offer a very short reply. 0.95. What is the ratio of the Earning from trade(constant 2005 US) of Vanuatu in 2010 to that in 2011?
Provide a succinct answer. 1.02. What is the difference between the highest and the second highest Earning from trade(constant 2005 US) in Burundi?
Provide a succinct answer. 1.09e+08. What is the difference between the highest and the second highest Earning from trade(constant 2005 US) in Swaziland?
Keep it short and to the point. 1.81e+06. What is the difference between the highest and the second highest Earning from trade(constant 2005 US) of Vanuatu?
Ensure brevity in your answer.  6.83e+06. What is the difference between the highest and the lowest Earning from trade(constant 2005 US) in Burundi?
Your answer should be very brief. 5.15e+08. What is the difference between the highest and the lowest Earning from trade(constant 2005 US) in Swaziland?
Provide a succinct answer. 2.95e+08. What is the difference between the highest and the lowest Earning from trade(constant 2005 US) of Vanuatu?
Ensure brevity in your answer.  1.05e+08. 